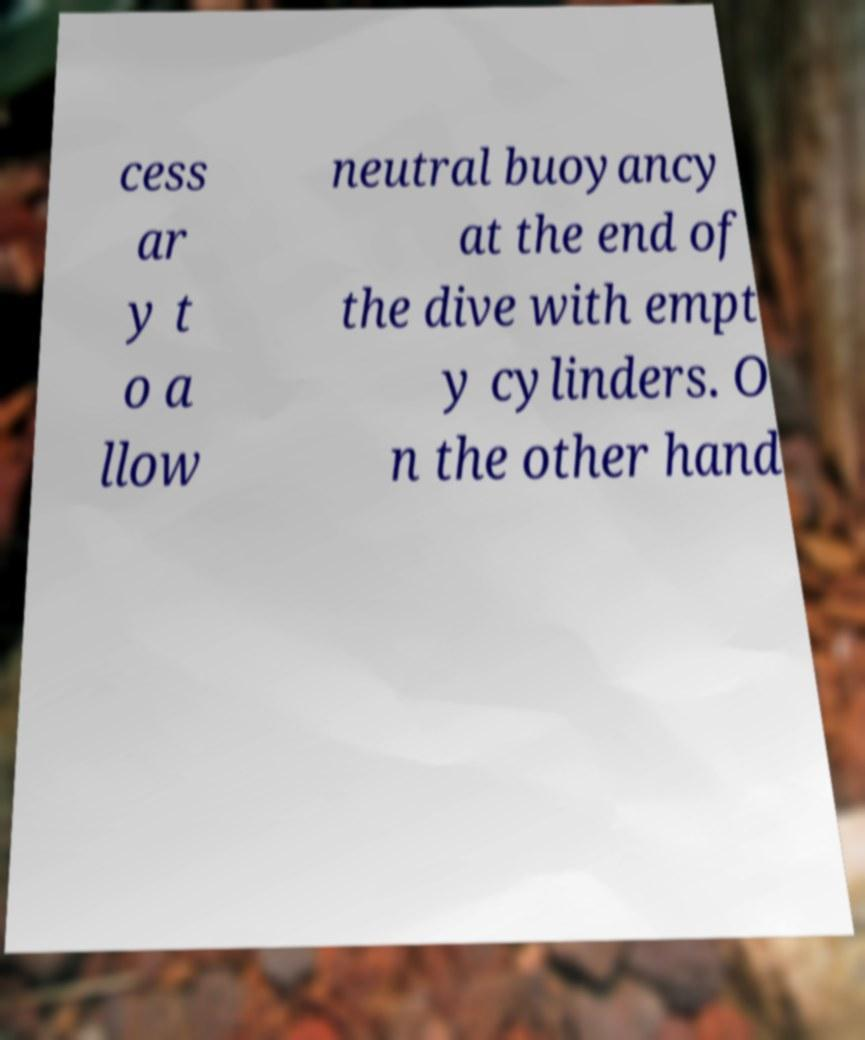Please read and relay the text visible in this image. What does it say? cess ar y t o a llow neutral buoyancy at the end of the dive with empt y cylinders. O n the other hand 